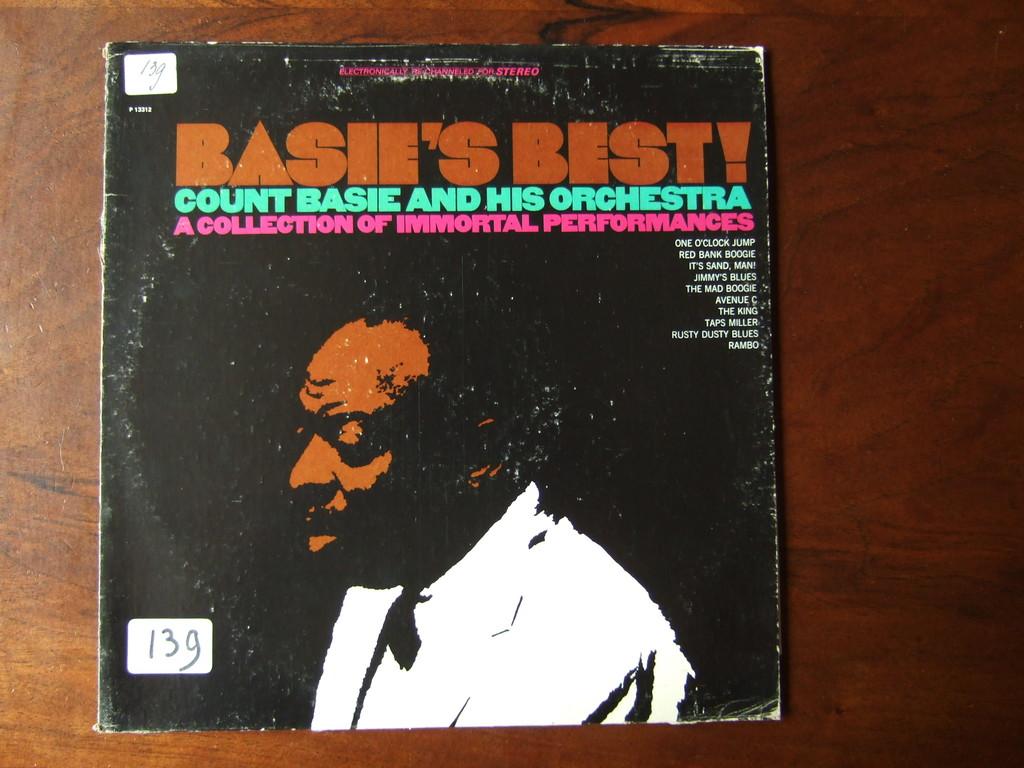What record is that?
Your response must be concise. Basie's best. What musician is mentioned?
Make the answer very short. Count basie. 